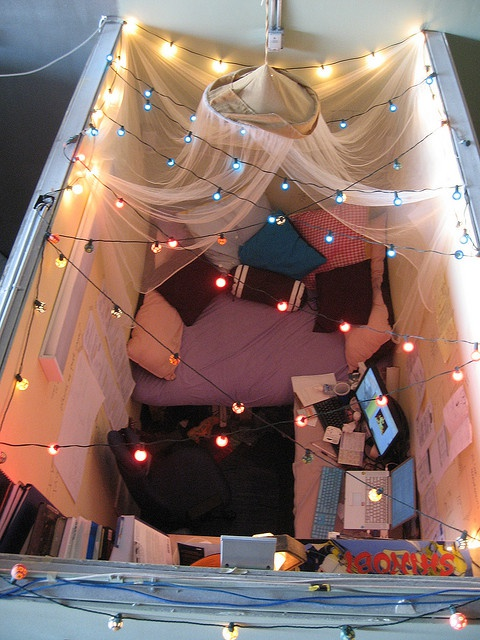Describe the objects in this image and their specific colors. I can see bed in gray, black, brown, and maroon tones, chair in gray, black, maroon, brown, and ivory tones, laptop in gray and darkgray tones, laptop in gray, black, lightblue, and maroon tones, and tv in gray, black, and lightblue tones in this image. 